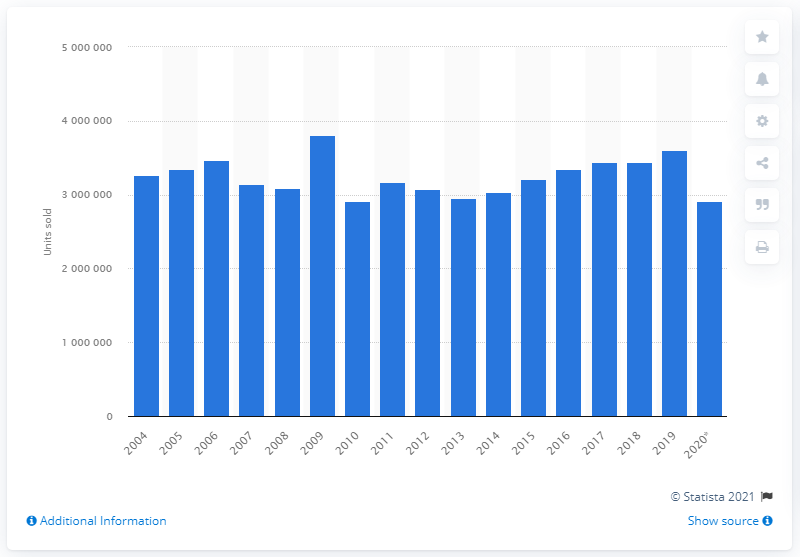Give some essential details in this illustration. In 2020, Germany's passenger car sales totaled 2,917,678 units. 